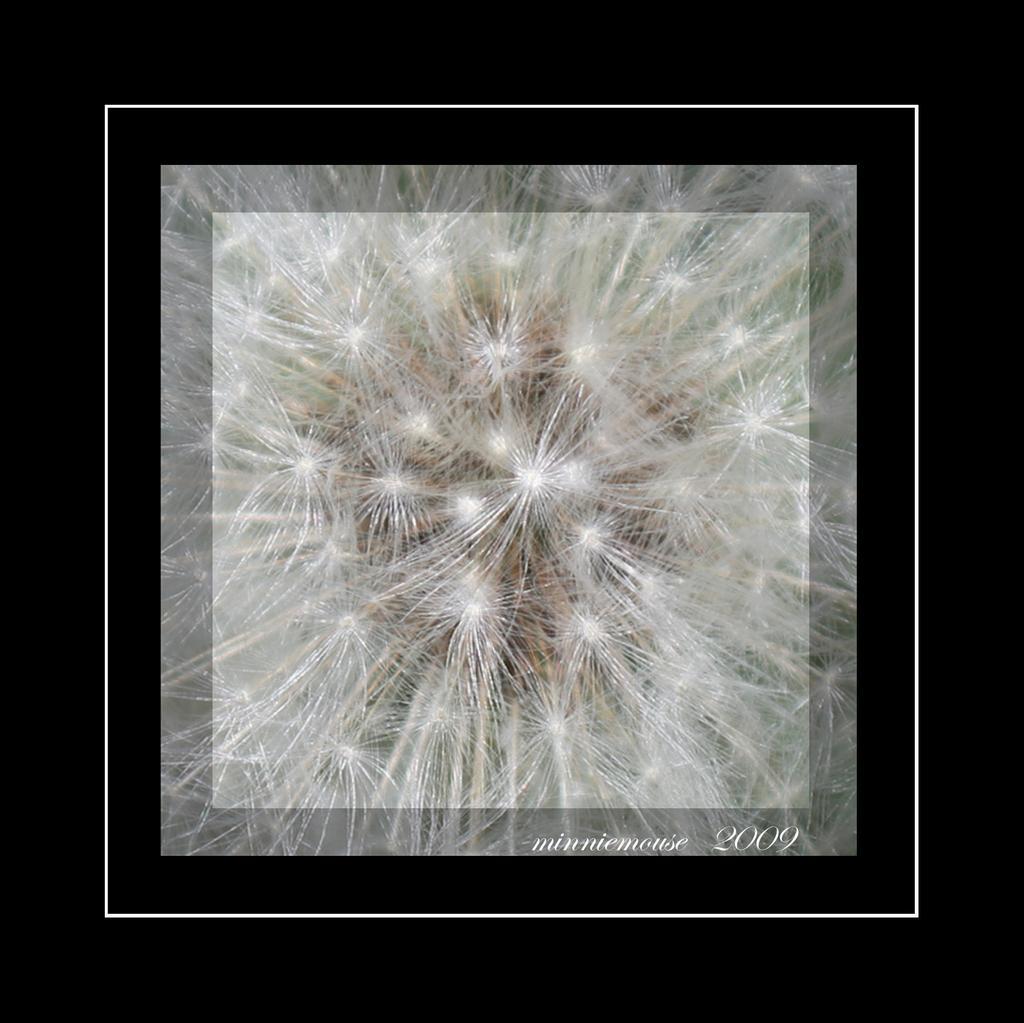How would you summarize this image in a sentence or two? In this picture I can see the white color things in the center and I see something is written on the bottom right of this picture and I see that it is black on all the sides. 